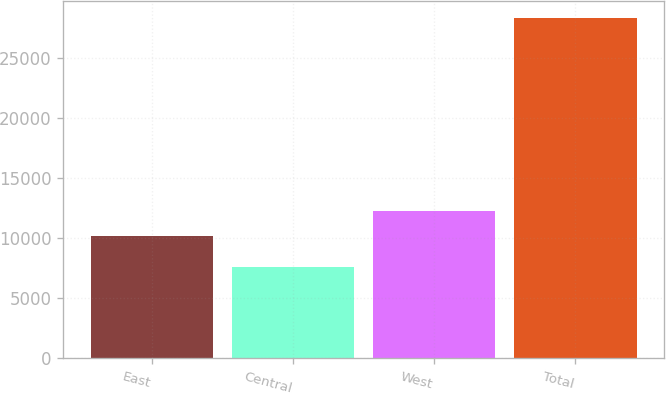Convert chart. <chart><loc_0><loc_0><loc_500><loc_500><bar_chart><fcel>East<fcel>Central<fcel>West<fcel>Total<nl><fcel>10192<fcel>7591<fcel>12270.2<fcel>28373<nl></chart> 